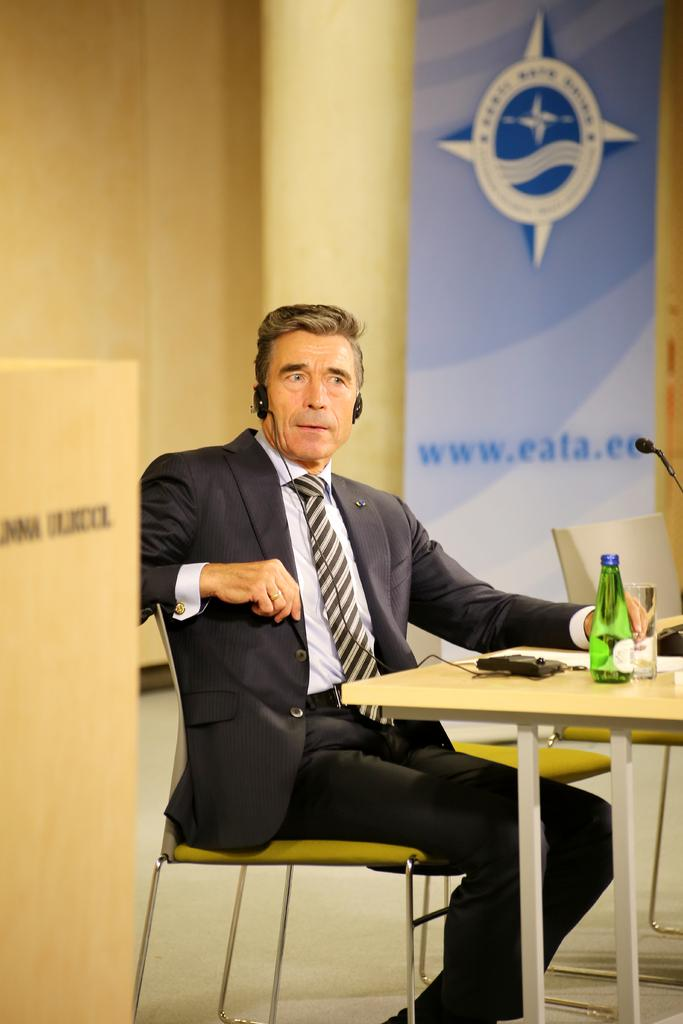What is the person in the image doing? The person is sitting on a chair. What is in front of the person? There is a table in front of the person. What objects can be seen on the table? There is a bottle and a glass on the table. What is visible behind the person? There is a banner behind the person. What is written on the banner? The banner has "www. eata. co" written on it. Is there a fireman fighting a fire in the image? No, there is no fireman or fire in the image. 